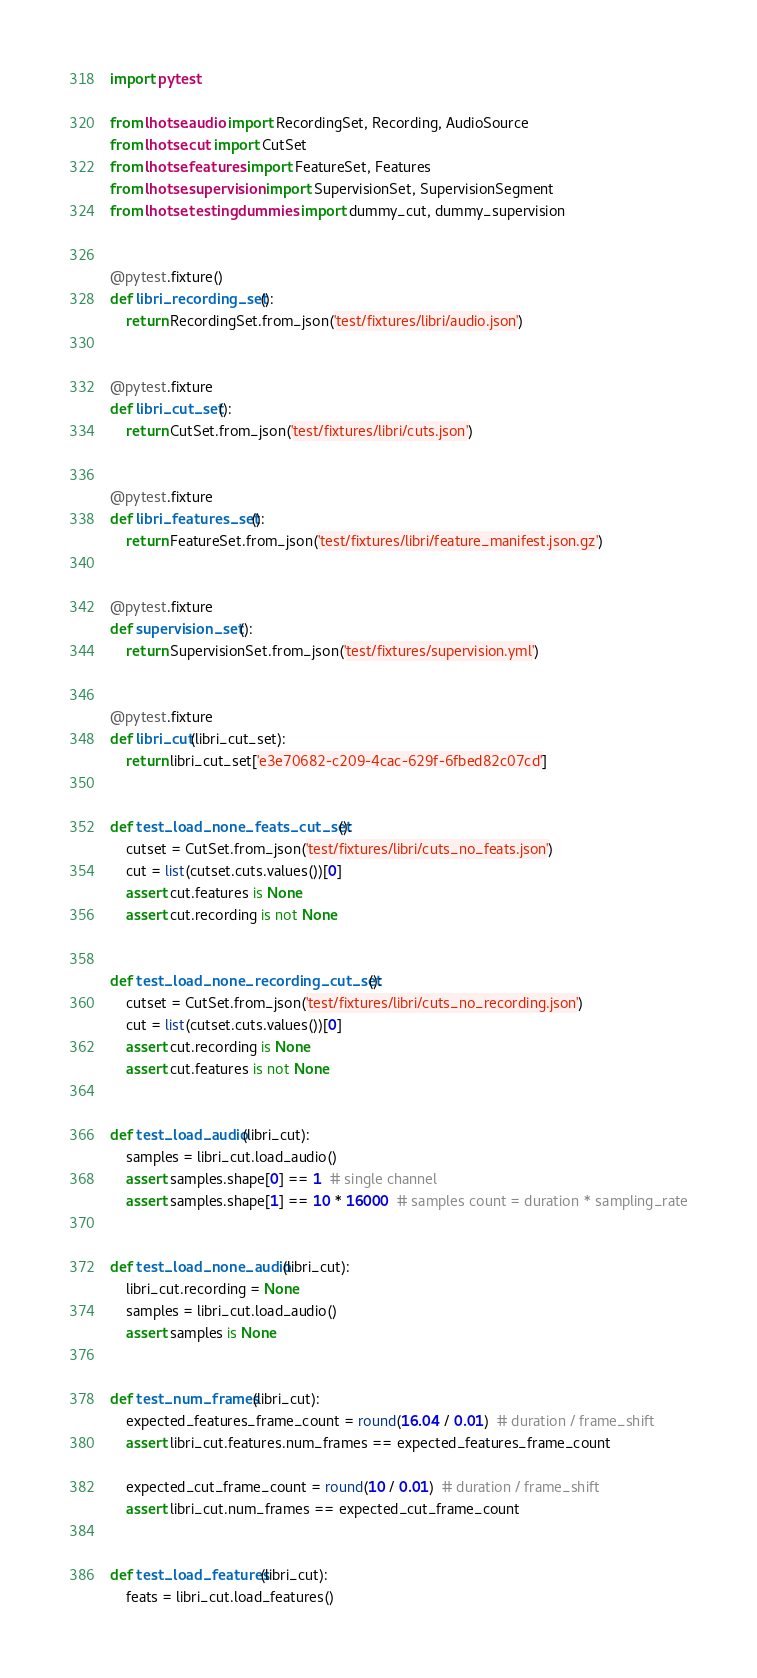Convert code to text. <code><loc_0><loc_0><loc_500><loc_500><_Python_>import pytest

from lhotse.audio import RecordingSet, Recording, AudioSource
from lhotse.cut import CutSet
from lhotse.features import FeatureSet, Features
from lhotse.supervision import SupervisionSet, SupervisionSegment
from lhotse.testing.dummies import dummy_cut, dummy_supervision


@pytest.fixture()
def libri_recording_set():
    return RecordingSet.from_json('test/fixtures/libri/audio.json')


@pytest.fixture
def libri_cut_set():
    return CutSet.from_json('test/fixtures/libri/cuts.json')


@pytest.fixture
def libri_features_set():
    return FeatureSet.from_json('test/fixtures/libri/feature_manifest.json.gz')


@pytest.fixture
def supervision_set():
    return SupervisionSet.from_json('test/fixtures/supervision.yml')


@pytest.fixture
def libri_cut(libri_cut_set):
    return libri_cut_set['e3e70682-c209-4cac-629f-6fbed82c07cd']


def test_load_none_feats_cut_set():
    cutset = CutSet.from_json('test/fixtures/libri/cuts_no_feats.json')
    cut = list(cutset.cuts.values())[0]
    assert cut.features is None
    assert cut.recording is not None


def test_load_none_recording_cut_set():
    cutset = CutSet.from_json('test/fixtures/libri/cuts_no_recording.json')
    cut = list(cutset.cuts.values())[0]
    assert cut.recording is None
    assert cut.features is not None


def test_load_audio(libri_cut):
    samples = libri_cut.load_audio()
    assert samples.shape[0] == 1  # single channel
    assert samples.shape[1] == 10 * 16000  # samples count = duration * sampling_rate


def test_load_none_audio(libri_cut):
    libri_cut.recording = None
    samples = libri_cut.load_audio()
    assert samples is None


def test_num_frames(libri_cut):
    expected_features_frame_count = round(16.04 / 0.01)  # duration / frame_shift
    assert libri_cut.features.num_frames == expected_features_frame_count

    expected_cut_frame_count = round(10 / 0.01)  # duration / frame_shift
    assert libri_cut.num_frames == expected_cut_frame_count


def test_load_features(libri_cut):
    feats = libri_cut.load_features()</code> 